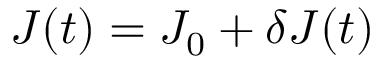Convert formula to latex. <formula><loc_0><loc_0><loc_500><loc_500>J ( t ) = J _ { 0 } + \delta J ( t )</formula> 